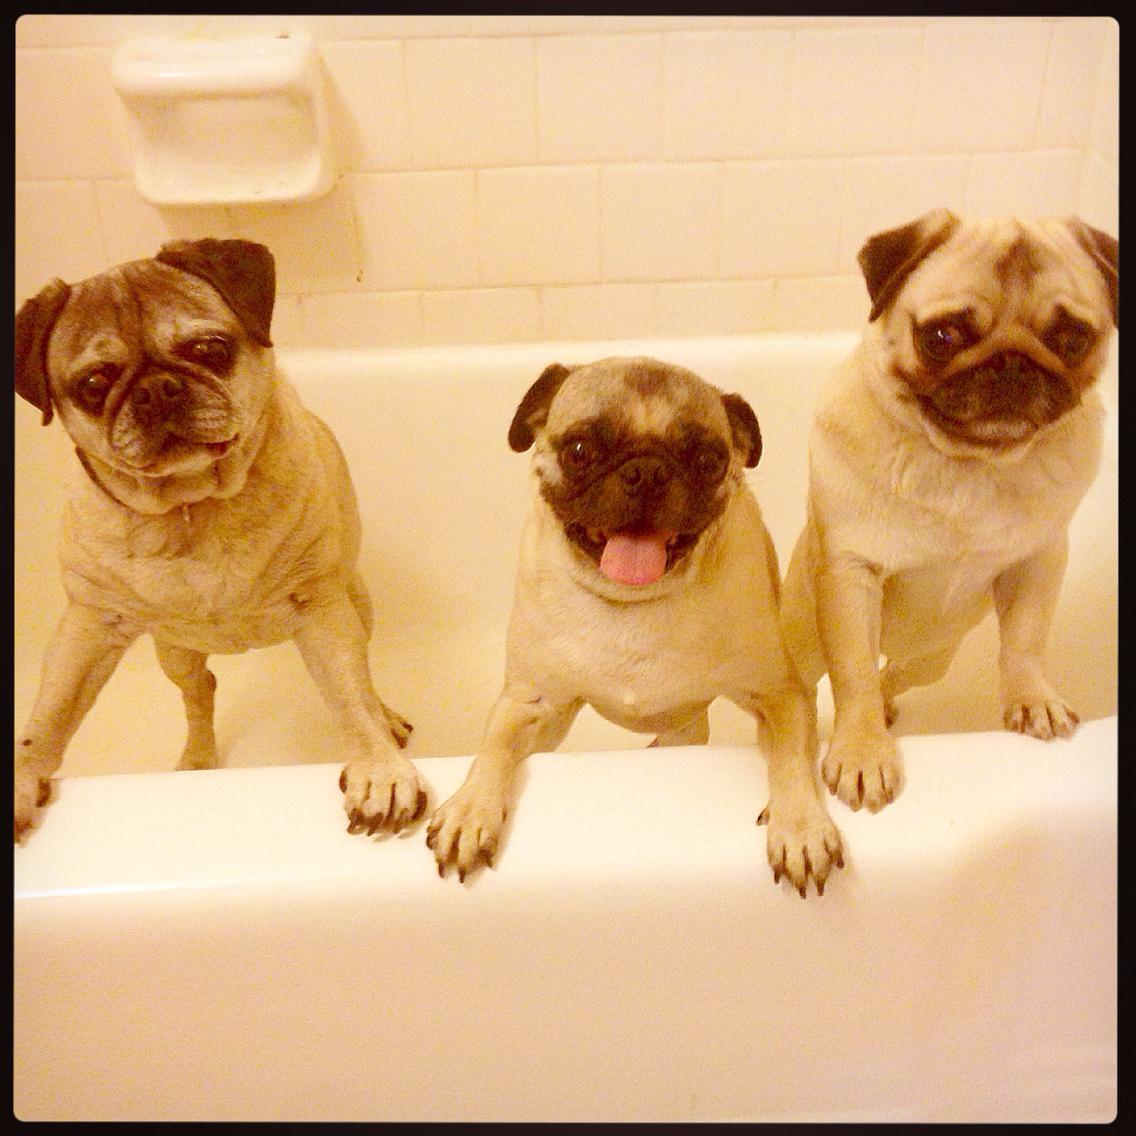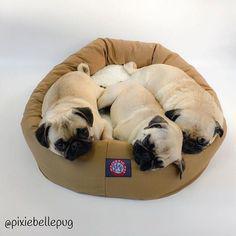The first image is the image on the left, the second image is the image on the right. For the images displayed, is the sentence "Three dogs have their front paws off the ground." factually correct? Answer yes or no. Yes. The first image is the image on the left, the second image is the image on the right. Evaluate the accuracy of this statement regarding the images: "One image shows a trio of pugs snoozing on a beige cushioned item, and the other image shows a row of three pugs, with paws draped on something white.". Is it true? Answer yes or no. Yes. 